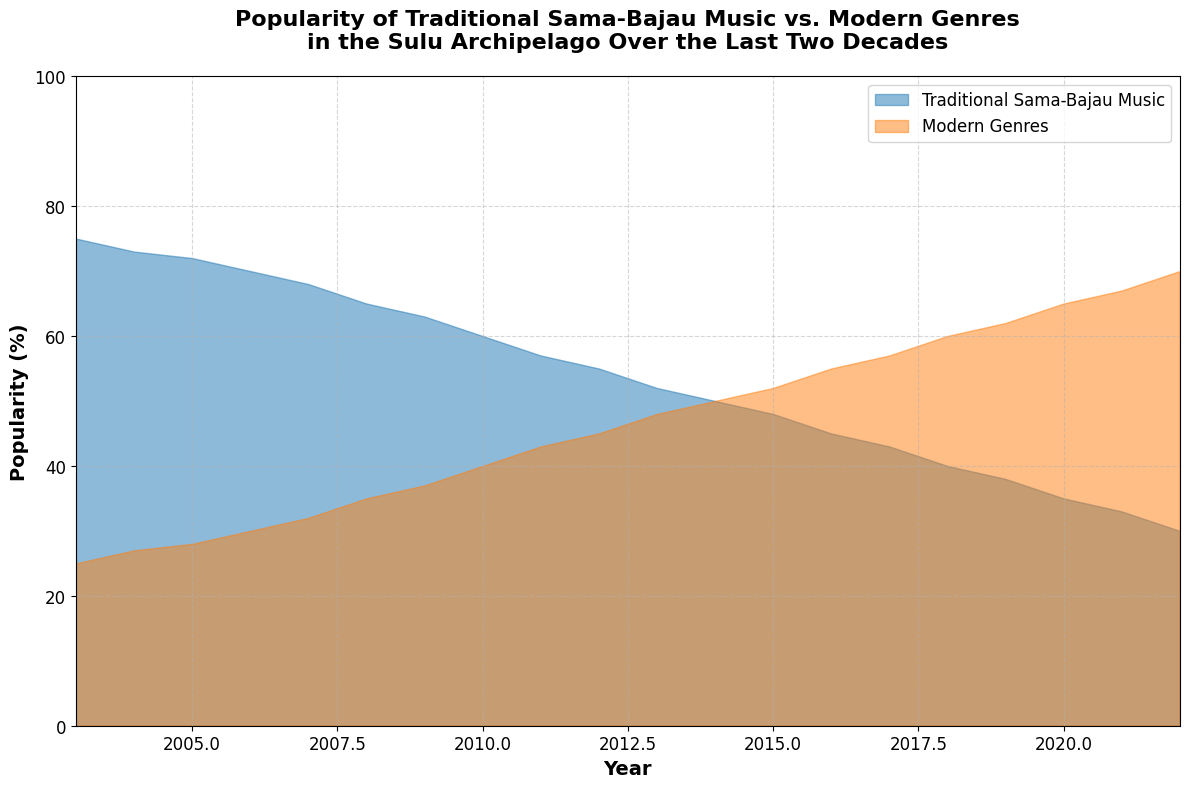What's the trend for Traditional Sama-Bajau Music's popularity over the last two decades? The trend can be identified by observing the declining area designated for Traditional Sama-Bajau Music from 2003 to 2022, with the popularity decreasing from 75% to 30%.
Answer: A declining trend In which year did Traditional Sama-Bajau Music and Modern Genres have equal popularity? By checking the point where the areas of both traditional music and modern genres meet, we can see they are equal in 2014.
Answer: 2014 How much did the popularity of Modern Genres increase from 2003 to 2022? Subtract the popularity in 2003 (25%) from the popularity in 2022 (70%). The increase is 70% - 25% = 45%.
Answer: 45% What is the difference in popularity between Traditional Sama-Bajau Music and Modern Genres in 2022? The popularity of Modern Genres in 2022 is 70%, and Traditional Sama-Bajau Music is 30%. Therefore, the difference is 70% - 30% = 40%.
Answer: 40% How did the popularity of Modern Genres change from 2010 to 2015? By looking at the values for 2010 and 2015, we can see the change. In 2010 it was 40%, and in 2015 it was 52%, indicating an increase of 52% - 40% = 12%.
Answer: Increased by 12% Which year saw the steepest decline in Traditional Sama-Bajau Music's popularity? By comparing the year-to-year changes, the steepest decline appears between 2011 (57%) and 2012 (55%), indicating a 2% decrease.
Answer: 2011 to 2012 During which years was the popularity of Traditional Sama-Bajau Music above 50%? Observing the area, we see the popularity was above 50% from 2003 to 2012, inclusively, where it starts at 75% in 2003 and ends at 50% in 2012.
Answer: 2003-2012 What was the average popularity of Modern Genres from 2003 to 2022? Calculate the average by summing the popularity values each year and dividing by the number of years (25+27+28+30+32+35+37+40+43+45+48+50+52+55+57+60+62+65+67+70) = 941/20.
Answer: 47.05% What is the total change in popularity for Traditional Sama-Bajau Music from 2003 to 2010? The initial popularity in 2003 was 75%, and in 2010 it was 60%. Hence, the total change is 75% - 60% = 15%.
Answer: 15% Between which consecutive years was the least change observed in the popularity of Modern Genres? By examining year-to-year changes, the least significant change is from 2011 (43%) to 2012 (45%), implying a 2% increase.
Answer: 2011 to 2012 